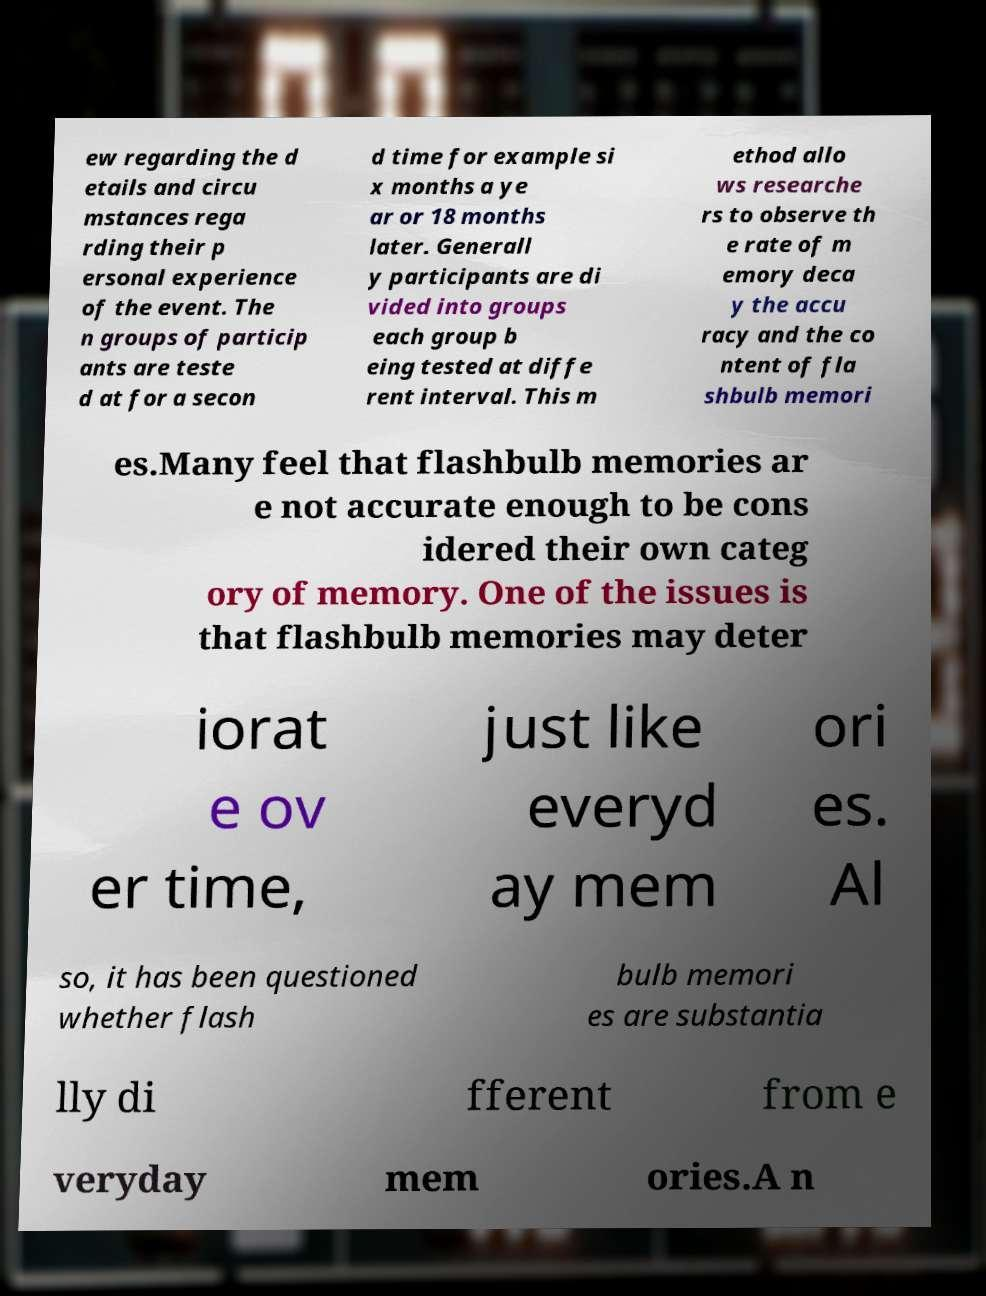Please read and relay the text visible in this image. What does it say? ew regarding the d etails and circu mstances rega rding their p ersonal experience of the event. The n groups of particip ants are teste d at for a secon d time for example si x months a ye ar or 18 months later. Generall y participants are di vided into groups each group b eing tested at diffe rent interval. This m ethod allo ws researche rs to observe th e rate of m emory deca y the accu racy and the co ntent of fla shbulb memori es.Many feel that flashbulb memories ar e not accurate enough to be cons idered their own categ ory of memory. One of the issues is that flashbulb memories may deter iorat e ov er time, just like everyd ay mem ori es. Al so, it has been questioned whether flash bulb memori es are substantia lly di fferent from e veryday mem ories.A n 